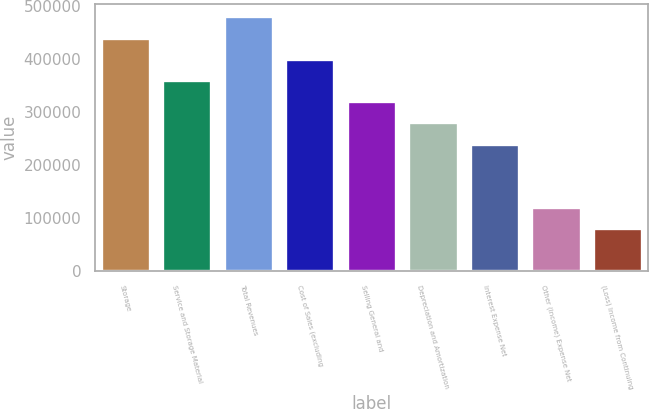<chart> <loc_0><loc_0><loc_500><loc_500><bar_chart><fcel>Storage<fcel>Service and Storage Material<fcel>Total Revenues<fcel>Cost of Sales (excluding<fcel>Selling General and<fcel>Depreciation and Amortization<fcel>Interest Expense Net<fcel>Other (Income) Expense Net<fcel>(Loss) Income from Continuing<nl><fcel>439913<fcel>359929<fcel>479905<fcel>399921<fcel>319937<fcel>279945<fcel>239953<fcel>119976<fcel>79984.2<nl></chart> 